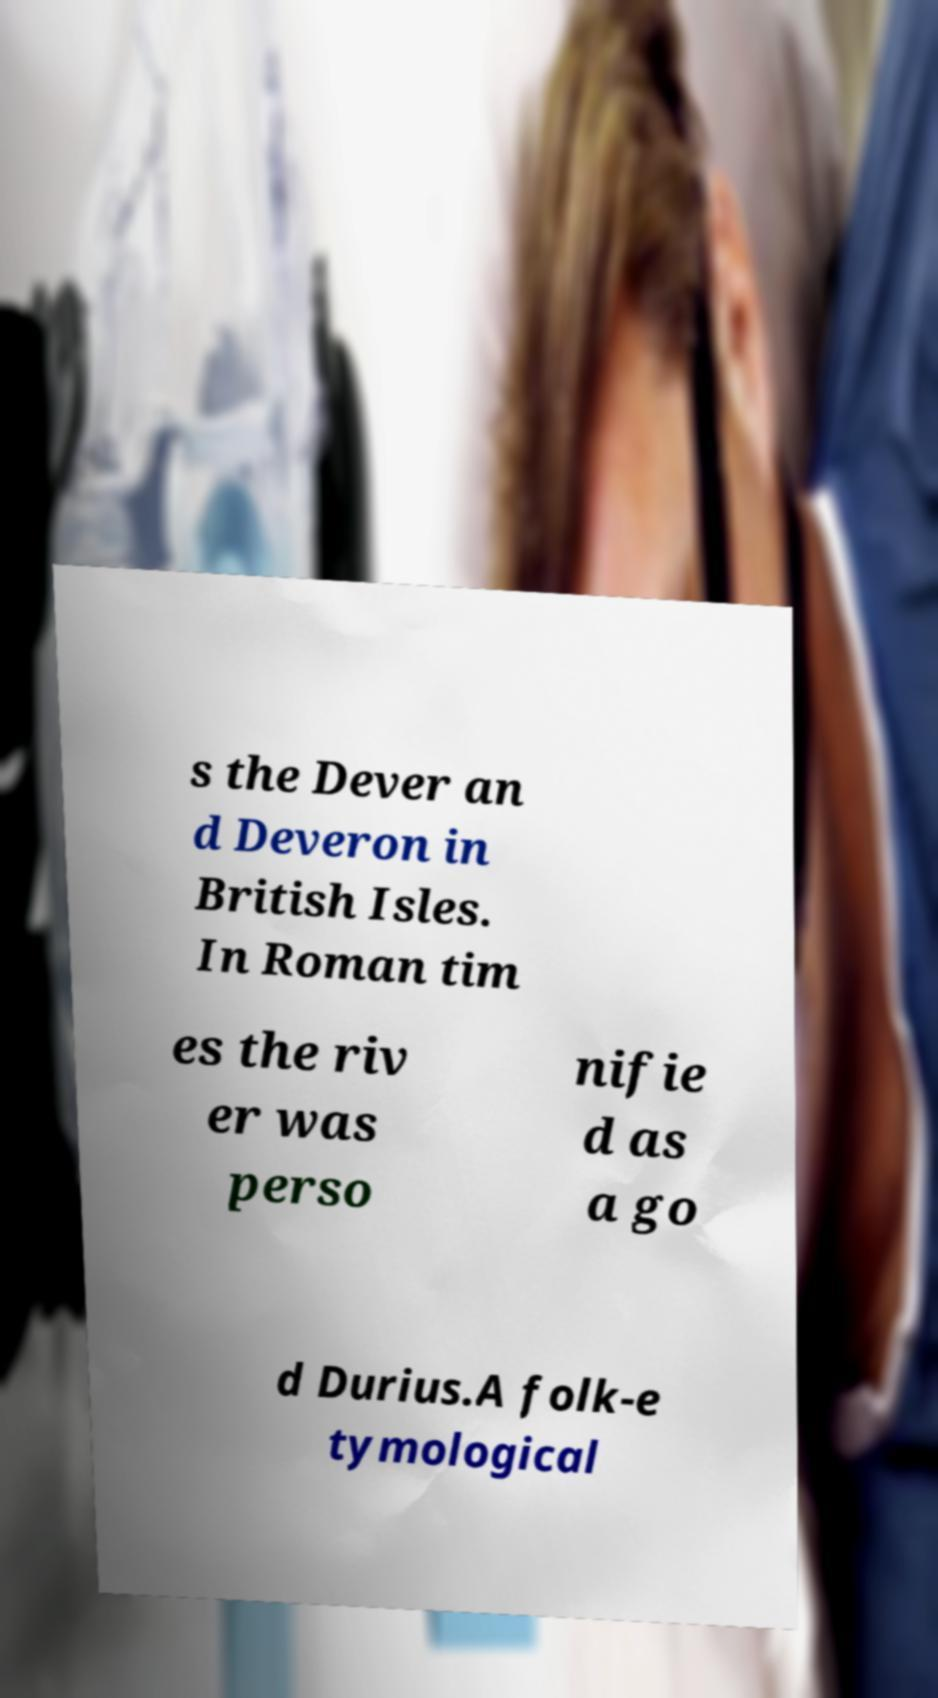Could you assist in decoding the text presented in this image and type it out clearly? s the Dever an d Deveron in British Isles. In Roman tim es the riv er was perso nifie d as a go d Durius.A folk-e tymological 